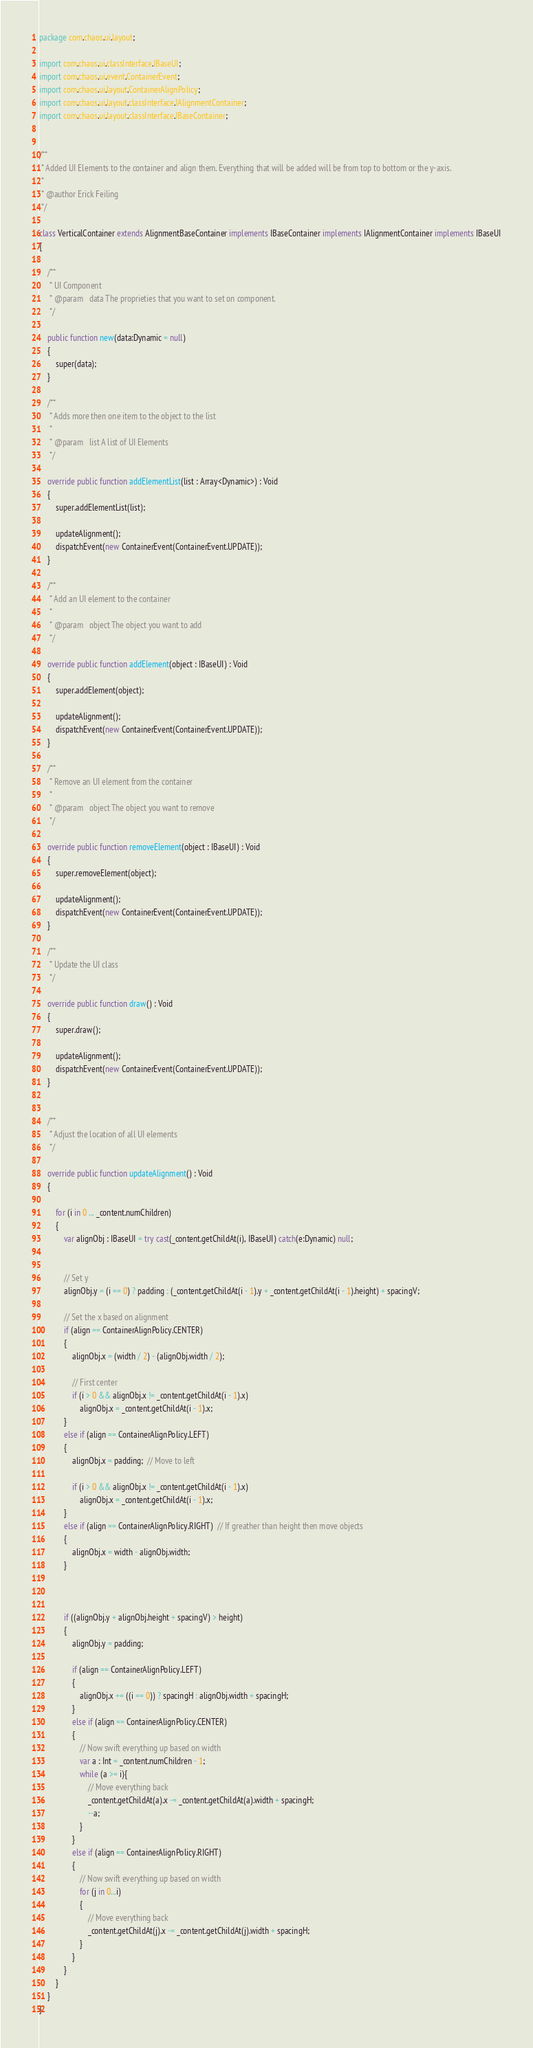Convert code to text. <code><loc_0><loc_0><loc_500><loc_500><_Haxe_>package com.chaos.ui.layout;

import com.chaos.ui.classInterface.IBaseUI;
import com.chaos.ui.event.ContainerEvent;
import com.chaos.ui.layout.ContainerAlignPolicy;
import com.chaos.ui.layout.classInterface.IAlignmentContainer;
import com.chaos.ui.layout.classInterface.IBaseContainer;


/**
 * Added UI Elements to the container and align them. Everything that will be added will be from top to bottom or the y-axis.
 *
 * @author Erick Feiling
 */

class VerticalContainer extends AlignmentBaseContainer implements IBaseContainer implements IAlignmentContainer implements IBaseUI
{
    
	/**
	 * UI Component 
	 * @param	data The proprieties that you want to set on component.
	 */
	
    public function new(data:Dynamic = null)
    {
        super(data);
    }
    
    /**
	 * Adds more then one item to the object to the list
	 *
	 * @param	list A list of UI Elements
	 */
    
    override public function addElementList(list : Array<Dynamic>) : Void
    {
        super.addElementList(list);
        
        updateAlignment();
        dispatchEvent(new ContainerEvent(ContainerEvent.UPDATE));
    }
    
    /**
	 * Add an UI element to the container
	 *
	 * @param	object The object you want to add
	 */
    
    override public function addElement(object : IBaseUI) : Void
    {
        super.addElement(object);
        
        updateAlignment();
        dispatchEvent(new ContainerEvent(ContainerEvent.UPDATE));
    }
    
    /**
	 * Remove an UI element from the container
	 *
	 * @param	object The object you want to remove
	 */
	
    override public function removeElement(object : IBaseUI) : Void
    {
        super.removeElement(object);
        
        updateAlignment();
        dispatchEvent(new ContainerEvent(ContainerEvent.UPDATE));
    }
    
    /**
	 * Update the UI class
	 */
    
    override public function draw() : Void
    {
        super.draw();
        
        updateAlignment();
        dispatchEvent(new ContainerEvent(ContainerEvent.UPDATE));
    }
	
	
    /**
	 * Adjust the location of all UI elements 
	 */	
	
    override public function updateAlignment() : Void
    {
        
        for (i in 0 ... _content.numChildren)
		{
            var alignObj : IBaseUI = try cast(_content.getChildAt(i), IBaseUI) catch(e:Dynamic) null;
            
			
            // Set y
            alignObj.y = (i == 0) ? padding : (_content.getChildAt(i - 1).y + _content.getChildAt(i - 1).height) + spacingV;
            
            // Set the x based on alignment
            if (align == ContainerAlignPolicy.CENTER) 
            {
                alignObj.x = (width / 2) - (alignObj.width / 2);
                
				// First center  
                if (i > 0 && alignObj.x != _content.getChildAt(i - 1).x) 
                    alignObj.x = _content.getChildAt(i - 1).x;
            }
            else if (align == ContainerAlignPolicy.LEFT) 
            {
                alignObj.x = padding;  // Move to left  
                
                if (i > 0 && alignObj.x != _content.getChildAt(i - 1).x) 
                    alignObj.x = _content.getChildAt(i - 1).x;
            }
            else if (align == ContainerAlignPolicy.RIGHT)  // If greather than height then move objects
            {
                alignObj.x = width - alignObj.width;
            }
            
            
            
            if ((alignObj.y + alignObj.height + spacingV) > height) 
            {
                alignObj.y = padding;
                
                if (align == ContainerAlignPolicy.LEFT) 
                {
                    alignObj.x += ((i == 0)) ? spacingH : alignObj.width + spacingH;
                }
                else if (align == ContainerAlignPolicy.CENTER) 
                {
                    // Now swift everything up based on width
                    var a : Int = _content.numChildren - 1;
                    while (a >= i){
                        // Move everything back
                        _content.getChildAt(a).x -= _content.getChildAt(a).width + spacingH;
                        --a;
                    }
                }
                else if (align == ContainerAlignPolicy.RIGHT) 
                {
                    // Now swift everything up based on width
                    for (j in 0...i)
					{
                        // Move everything back
                        _content.getChildAt(j).x -= _content.getChildAt(j).width + spacingH;
                    }
                }
            }
        }
    }
}

</code> 